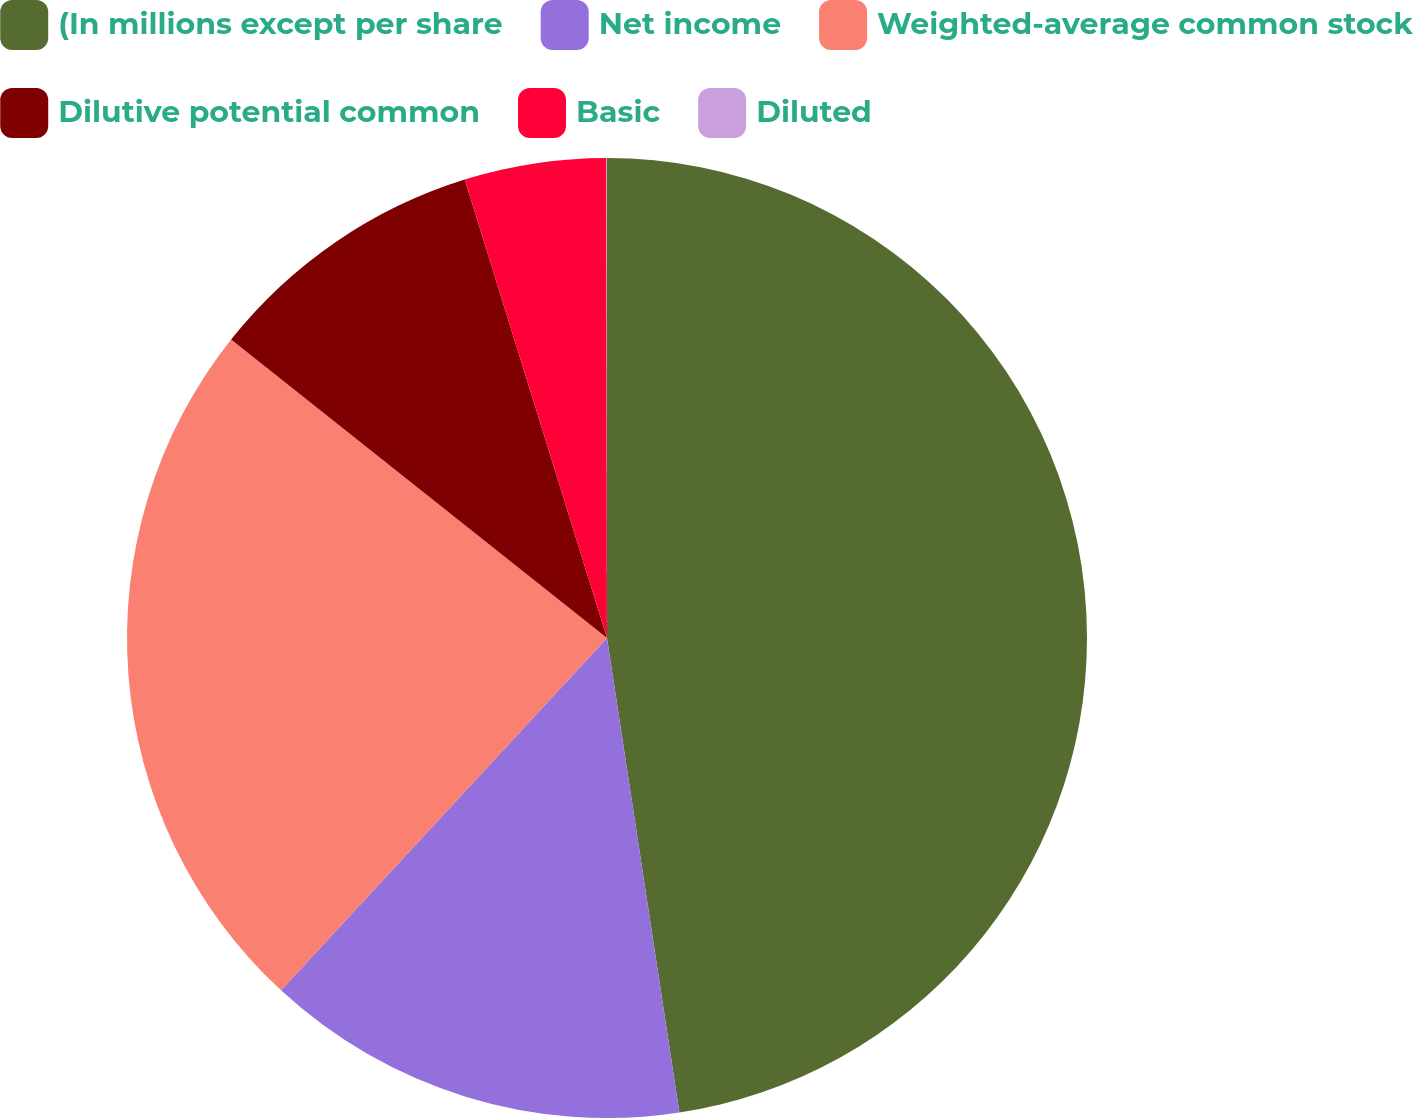Convert chart. <chart><loc_0><loc_0><loc_500><loc_500><pie_chart><fcel>(In millions except per share<fcel>Net income<fcel>Weighted-average common stock<fcel>Dilutive potential common<fcel>Basic<fcel>Diluted<nl><fcel>47.59%<fcel>14.29%<fcel>23.8%<fcel>9.53%<fcel>4.77%<fcel>0.02%<nl></chart> 